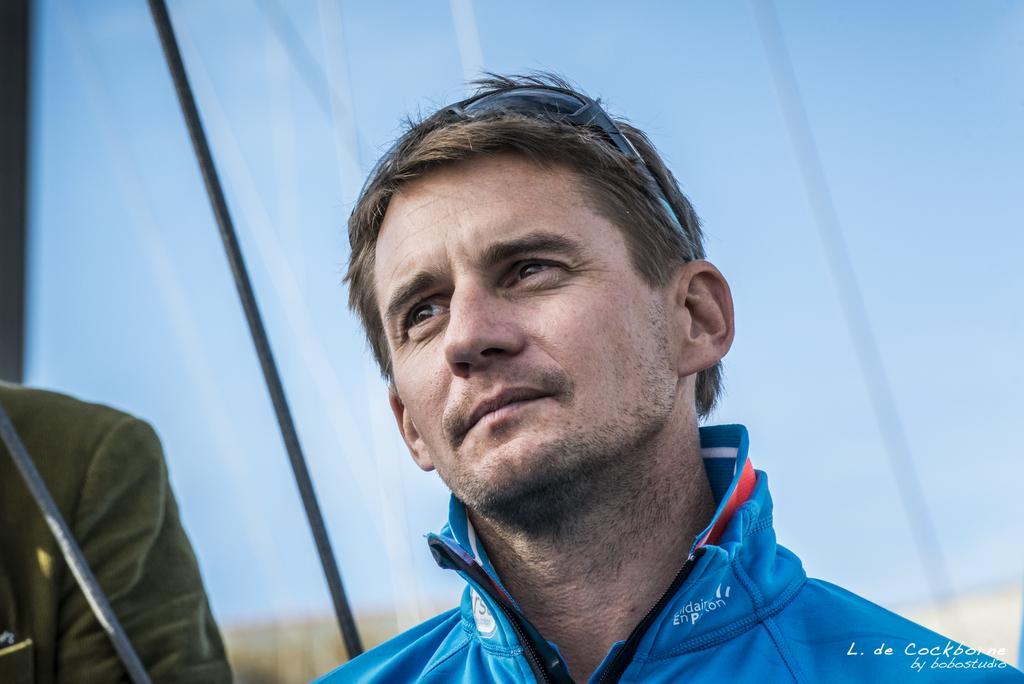Can you describe this image briefly? In this image we can see few people. There are few ropes in the image. We can see the sky in the image. There is some text at the bottom of the image. 